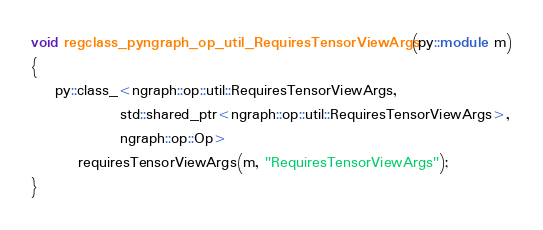Convert code to text. <code><loc_0><loc_0><loc_500><loc_500><_C++_>void regclass_pyngraph_op_util_RequiresTensorViewArgs(py::module m)
{
    py::class_<ngraph::op::util::RequiresTensorViewArgs,
               std::shared_ptr<ngraph::op::util::RequiresTensorViewArgs>,
               ngraph::op::Op>
        requiresTensorViewArgs(m, "RequiresTensorViewArgs");
}
</code> 